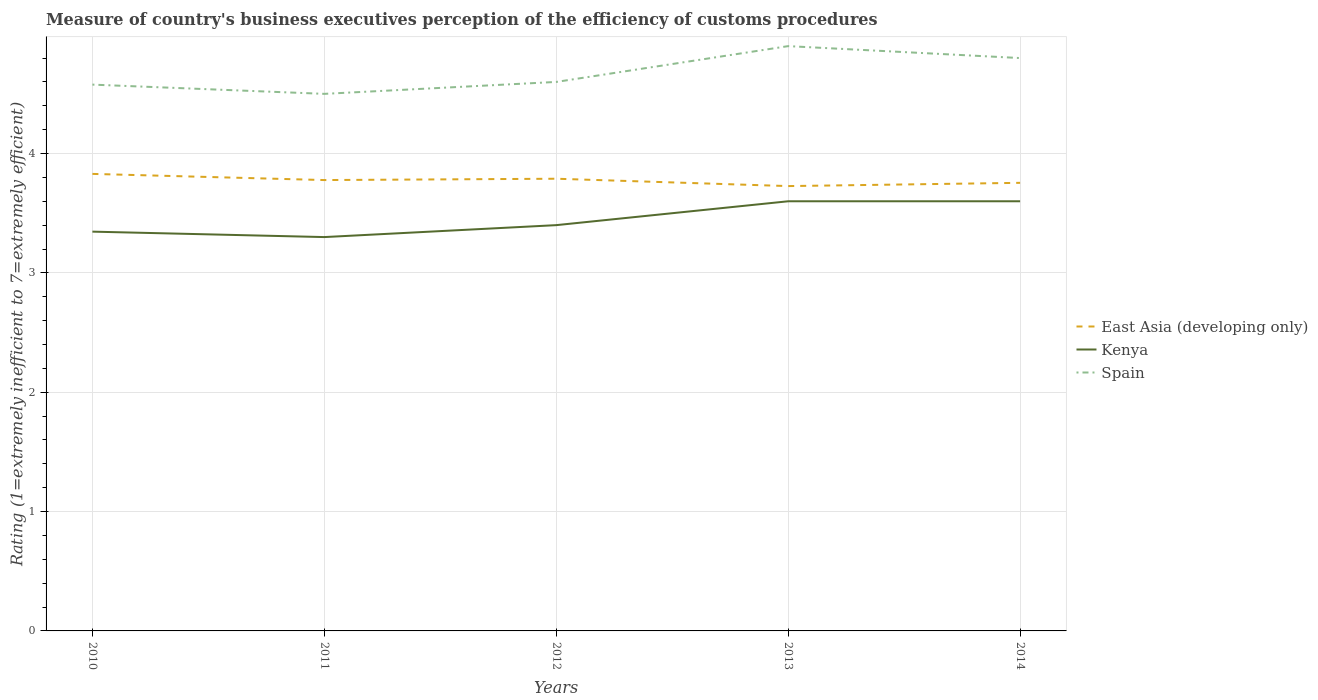How many different coloured lines are there?
Your answer should be compact. 3. Is the number of lines equal to the number of legend labels?
Offer a terse response. Yes. Across all years, what is the maximum rating of the efficiency of customs procedure in Spain?
Keep it short and to the point. 4.5. What is the total rating of the efficiency of customs procedure in East Asia (developing only) in the graph?
Provide a short and direct response. 0.05. What is the difference between the highest and the second highest rating of the efficiency of customs procedure in East Asia (developing only)?
Provide a succinct answer. 0.1. What is the difference between the highest and the lowest rating of the efficiency of customs procedure in East Asia (developing only)?
Your answer should be compact. 3. Is the rating of the efficiency of customs procedure in East Asia (developing only) strictly greater than the rating of the efficiency of customs procedure in Spain over the years?
Make the answer very short. Yes. How many lines are there?
Provide a short and direct response. 3. Where does the legend appear in the graph?
Offer a very short reply. Center right. How are the legend labels stacked?
Offer a very short reply. Vertical. What is the title of the graph?
Keep it short and to the point. Measure of country's business executives perception of the efficiency of customs procedures. Does "Swaziland" appear as one of the legend labels in the graph?
Your response must be concise. No. What is the label or title of the Y-axis?
Offer a terse response. Rating (1=extremely inefficient to 7=extremely efficient). What is the Rating (1=extremely inefficient to 7=extremely efficient) in East Asia (developing only) in 2010?
Your answer should be compact. 3.83. What is the Rating (1=extremely inefficient to 7=extremely efficient) in Kenya in 2010?
Keep it short and to the point. 3.35. What is the Rating (1=extremely inefficient to 7=extremely efficient) in Spain in 2010?
Provide a succinct answer. 4.58. What is the Rating (1=extremely inefficient to 7=extremely efficient) in East Asia (developing only) in 2011?
Provide a succinct answer. 3.78. What is the Rating (1=extremely inefficient to 7=extremely efficient) of Kenya in 2011?
Provide a short and direct response. 3.3. What is the Rating (1=extremely inefficient to 7=extremely efficient) in East Asia (developing only) in 2012?
Your answer should be compact. 3.79. What is the Rating (1=extremely inefficient to 7=extremely efficient) of East Asia (developing only) in 2013?
Provide a succinct answer. 3.73. What is the Rating (1=extremely inefficient to 7=extremely efficient) in Kenya in 2013?
Make the answer very short. 3.6. What is the Rating (1=extremely inefficient to 7=extremely efficient) of East Asia (developing only) in 2014?
Give a very brief answer. 3.75. What is the Rating (1=extremely inefficient to 7=extremely efficient) of Kenya in 2014?
Your answer should be compact. 3.6. Across all years, what is the maximum Rating (1=extremely inefficient to 7=extremely efficient) in East Asia (developing only)?
Keep it short and to the point. 3.83. Across all years, what is the maximum Rating (1=extremely inefficient to 7=extremely efficient) of Kenya?
Your answer should be very brief. 3.6. Across all years, what is the minimum Rating (1=extremely inefficient to 7=extremely efficient) of East Asia (developing only)?
Your answer should be compact. 3.73. Across all years, what is the minimum Rating (1=extremely inefficient to 7=extremely efficient) of Kenya?
Make the answer very short. 3.3. What is the total Rating (1=extremely inefficient to 7=extremely efficient) in East Asia (developing only) in the graph?
Make the answer very short. 18.88. What is the total Rating (1=extremely inefficient to 7=extremely efficient) of Kenya in the graph?
Keep it short and to the point. 17.25. What is the total Rating (1=extremely inefficient to 7=extremely efficient) in Spain in the graph?
Give a very brief answer. 23.38. What is the difference between the Rating (1=extremely inefficient to 7=extremely efficient) in East Asia (developing only) in 2010 and that in 2011?
Your answer should be very brief. 0.05. What is the difference between the Rating (1=extremely inefficient to 7=extremely efficient) of Kenya in 2010 and that in 2011?
Offer a terse response. 0.05. What is the difference between the Rating (1=extremely inefficient to 7=extremely efficient) in Spain in 2010 and that in 2011?
Make the answer very short. 0.08. What is the difference between the Rating (1=extremely inefficient to 7=extremely efficient) of East Asia (developing only) in 2010 and that in 2012?
Your answer should be compact. 0.04. What is the difference between the Rating (1=extremely inefficient to 7=extremely efficient) of Kenya in 2010 and that in 2012?
Your response must be concise. -0.05. What is the difference between the Rating (1=extremely inefficient to 7=extremely efficient) in Spain in 2010 and that in 2012?
Your answer should be very brief. -0.02. What is the difference between the Rating (1=extremely inefficient to 7=extremely efficient) of East Asia (developing only) in 2010 and that in 2013?
Your response must be concise. 0.1. What is the difference between the Rating (1=extremely inefficient to 7=extremely efficient) of Kenya in 2010 and that in 2013?
Provide a short and direct response. -0.25. What is the difference between the Rating (1=extremely inefficient to 7=extremely efficient) in Spain in 2010 and that in 2013?
Your answer should be compact. -0.32. What is the difference between the Rating (1=extremely inefficient to 7=extremely efficient) of East Asia (developing only) in 2010 and that in 2014?
Offer a terse response. 0.07. What is the difference between the Rating (1=extremely inefficient to 7=extremely efficient) in Kenya in 2010 and that in 2014?
Keep it short and to the point. -0.25. What is the difference between the Rating (1=extremely inefficient to 7=extremely efficient) in Spain in 2010 and that in 2014?
Give a very brief answer. -0.22. What is the difference between the Rating (1=extremely inefficient to 7=extremely efficient) of East Asia (developing only) in 2011 and that in 2012?
Offer a very short reply. -0.01. What is the difference between the Rating (1=extremely inefficient to 7=extremely efficient) in Kenya in 2011 and that in 2012?
Your response must be concise. -0.1. What is the difference between the Rating (1=extremely inefficient to 7=extremely efficient) of Spain in 2011 and that in 2012?
Ensure brevity in your answer.  -0.1. What is the difference between the Rating (1=extremely inefficient to 7=extremely efficient) in East Asia (developing only) in 2011 and that in 2013?
Your answer should be very brief. 0.05. What is the difference between the Rating (1=extremely inefficient to 7=extremely efficient) in Kenya in 2011 and that in 2013?
Your answer should be compact. -0.3. What is the difference between the Rating (1=extremely inefficient to 7=extremely efficient) in Spain in 2011 and that in 2013?
Offer a very short reply. -0.4. What is the difference between the Rating (1=extremely inefficient to 7=extremely efficient) of East Asia (developing only) in 2011 and that in 2014?
Your response must be concise. 0.02. What is the difference between the Rating (1=extremely inefficient to 7=extremely efficient) in East Asia (developing only) in 2012 and that in 2013?
Your answer should be very brief. 0.06. What is the difference between the Rating (1=extremely inefficient to 7=extremely efficient) of Kenya in 2012 and that in 2013?
Offer a terse response. -0.2. What is the difference between the Rating (1=extremely inefficient to 7=extremely efficient) in Spain in 2012 and that in 2013?
Your answer should be compact. -0.3. What is the difference between the Rating (1=extremely inefficient to 7=extremely efficient) of East Asia (developing only) in 2012 and that in 2014?
Keep it short and to the point. 0.03. What is the difference between the Rating (1=extremely inefficient to 7=extremely efficient) in Kenya in 2012 and that in 2014?
Your answer should be compact. -0.2. What is the difference between the Rating (1=extremely inefficient to 7=extremely efficient) of East Asia (developing only) in 2013 and that in 2014?
Provide a succinct answer. -0.03. What is the difference between the Rating (1=extremely inefficient to 7=extremely efficient) in Spain in 2013 and that in 2014?
Give a very brief answer. 0.1. What is the difference between the Rating (1=extremely inefficient to 7=extremely efficient) in East Asia (developing only) in 2010 and the Rating (1=extremely inefficient to 7=extremely efficient) in Kenya in 2011?
Make the answer very short. 0.53. What is the difference between the Rating (1=extremely inefficient to 7=extremely efficient) in East Asia (developing only) in 2010 and the Rating (1=extremely inefficient to 7=extremely efficient) in Spain in 2011?
Make the answer very short. -0.67. What is the difference between the Rating (1=extremely inefficient to 7=extremely efficient) in Kenya in 2010 and the Rating (1=extremely inefficient to 7=extremely efficient) in Spain in 2011?
Make the answer very short. -1.15. What is the difference between the Rating (1=extremely inefficient to 7=extremely efficient) in East Asia (developing only) in 2010 and the Rating (1=extremely inefficient to 7=extremely efficient) in Kenya in 2012?
Give a very brief answer. 0.43. What is the difference between the Rating (1=extremely inefficient to 7=extremely efficient) of East Asia (developing only) in 2010 and the Rating (1=extremely inefficient to 7=extremely efficient) of Spain in 2012?
Keep it short and to the point. -0.77. What is the difference between the Rating (1=extremely inefficient to 7=extremely efficient) in Kenya in 2010 and the Rating (1=extremely inefficient to 7=extremely efficient) in Spain in 2012?
Your answer should be very brief. -1.25. What is the difference between the Rating (1=extremely inefficient to 7=extremely efficient) of East Asia (developing only) in 2010 and the Rating (1=extremely inefficient to 7=extremely efficient) of Kenya in 2013?
Provide a short and direct response. 0.23. What is the difference between the Rating (1=extremely inefficient to 7=extremely efficient) in East Asia (developing only) in 2010 and the Rating (1=extremely inefficient to 7=extremely efficient) in Spain in 2013?
Ensure brevity in your answer.  -1.07. What is the difference between the Rating (1=extremely inefficient to 7=extremely efficient) of Kenya in 2010 and the Rating (1=extremely inefficient to 7=extremely efficient) of Spain in 2013?
Give a very brief answer. -1.55. What is the difference between the Rating (1=extremely inefficient to 7=extremely efficient) of East Asia (developing only) in 2010 and the Rating (1=extremely inefficient to 7=extremely efficient) of Kenya in 2014?
Your answer should be very brief. 0.23. What is the difference between the Rating (1=extremely inefficient to 7=extremely efficient) of East Asia (developing only) in 2010 and the Rating (1=extremely inefficient to 7=extremely efficient) of Spain in 2014?
Your answer should be very brief. -0.97. What is the difference between the Rating (1=extremely inefficient to 7=extremely efficient) of Kenya in 2010 and the Rating (1=extremely inefficient to 7=extremely efficient) of Spain in 2014?
Offer a terse response. -1.45. What is the difference between the Rating (1=extremely inefficient to 7=extremely efficient) in East Asia (developing only) in 2011 and the Rating (1=extremely inefficient to 7=extremely efficient) in Kenya in 2012?
Provide a succinct answer. 0.38. What is the difference between the Rating (1=extremely inefficient to 7=extremely efficient) of East Asia (developing only) in 2011 and the Rating (1=extremely inefficient to 7=extremely efficient) of Spain in 2012?
Ensure brevity in your answer.  -0.82. What is the difference between the Rating (1=extremely inefficient to 7=extremely efficient) in East Asia (developing only) in 2011 and the Rating (1=extremely inefficient to 7=extremely efficient) in Kenya in 2013?
Your answer should be very brief. 0.18. What is the difference between the Rating (1=extremely inefficient to 7=extremely efficient) in East Asia (developing only) in 2011 and the Rating (1=extremely inefficient to 7=extremely efficient) in Spain in 2013?
Your response must be concise. -1.12. What is the difference between the Rating (1=extremely inefficient to 7=extremely efficient) of East Asia (developing only) in 2011 and the Rating (1=extremely inefficient to 7=extremely efficient) of Kenya in 2014?
Provide a short and direct response. 0.18. What is the difference between the Rating (1=extremely inefficient to 7=extremely efficient) of East Asia (developing only) in 2011 and the Rating (1=extremely inefficient to 7=extremely efficient) of Spain in 2014?
Give a very brief answer. -1.02. What is the difference between the Rating (1=extremely inefficient to 7=extremely efficient) of Kenya in 2011 and the Rating (1=extremely inefficient to 7=extremely efficient) of Spain in 2014?
Offer a terse response. -1.5. What is the difference between the Rating (1=extremely inefficient to 7=extremely efficient) of East Asia (developing only) in 2012 and the Rating (1=extremely inefficient to 7=extremely efficient) of Kenya in 2013?
Keep it short and to the point. 0.19. What is the difference between the Rating (1=extremely inefficient to 7=extremely efficient) of East Asia (developing only) in 2012 and the Rating (1=extremely inefficient to 7=extremely efficient) of Spain in 2013?
Ensure brevity in your answer.  -1.11. What is the difference between the Rating (1=extremely inefficient to 7=extremely efficient) in East Asia (developing only) in 2012 and the Rating (1=extremely inefficient to 7=extremely efficient) in Kenya in 2014?
Keep it short and to the point. 0.19. What is the difference between the Rating (1=extremely inefficient to 7=extremely efficient) in East Asia (developing only) in 2012 and the Rating (1=extremely inefficient to 7=extremely efficient) in Spain in 2014?
Your response must be concise. -1.01. What is the difference between the Rating (1=extremely inefficient to 7=extremely efficient) of Kenya in 2012 and the Rating (1=extremely inefficient to 7=extremely efficient) of Spain in 2014?
Make the answer very short. -1.4. What is the difference between the Rating (1=extremely inefficient to 7=extremely efficient) in East Asia (developing only) in 2013 and the Rating (1=extremely inefficient to 7=extremely efficient) in Kenya in 2014?
Offer a terse response. 0.13. What is the difference between the Rating (1=extremely inefficient to 7=extremely efficient) in East Asia (developing only) in 2013 and the Rating (1=extremely inefficient to 7=extremely efficient) in Spain in 2014?
Your response must be concise. -1.07. What is the average Rating (1=extremely inefficient to 7=extremely efficient) in East Asia (developing only) per year?
Offer a very short reply. 3.78. What is the average Rating (1=extremely inefficient to 7=extremely efficient) of Kenya per year?
Make the answer very short. 3.45. What is the average Rating (1=extremely inefficient to 7=extremely efficient) in Spain per year?
Offer a very short reply. 4.68. In the year 2010, what is the difference between the Rating (1=extremely inefficient to 7=extremely efficient) of East Asia (developing only) and Rating (1=extremely inefficient to 7=extremely efficient) of Kenya?
Provide a succinct answer. 0.48. In the year 2010, what is the difference between the Rating (1=extremely inefficient to 7=extremely efficient) of East Asia (developing only) and Rating (1=extremely inefficient to 7=extremely efficient) of Spain?
Your answer should be very brief. -0.75. In the year 2010, what is the difference between the Rating (1=extremely inefficient to 7=extremely efficient) of Kenya and Rating (1=extremely inefficient to 7=extremely efficient) of Spain?
Provide a short and direct response. -1.23. In the year 2011, what is the difference between the Rating (1=extremely inefficient to 7=extremely efficient) of East Asia (developing only) and Rating (1=extremely inefficient to 7=extremely efficient) of Kenya?
Provide a succinct answer. 0.48. In the year 2011, what is the difference between the Rating (1=extremely inefficient to 7=extremely efficient) in East Asia (developing only) and Rating (1=extremely inefficient to 7=extremely efficient) in Spain?
Keep it short and to the point. -0.72. In the year 2011, what is the difference between the Rating (1=extremely inefficient to 7=extremely efficient) in Kenya and Rating (1=extremely inefficient to 7=extremely efficient) in Spain?
Your response must be concise. -1.2. In the year 2012, what is the difference between the Rating (1=extremely inefficient to 7=extremely efficient) in East Asia (developing only) and Rating (1=extremely inefficient to 7=extremely efficient) in Kenya?
Your answer should be compact. 0.39. In the year 2012, what is the difference between the Rating (1=extremely inefficient to 7=extremely efficient) of East Asia (developing only) and Rating (1=extremely inefficient to 7=extremely efficient) of Spain?
Make the answer very short. -0.81. In the year 2013, what is the difference between the Rating (1=extremely inefficient to 7=extremely efficient) of East Asia (developing only) and Rating (1=extremely inefficient to 7=extremely efficient) of Kenya?
Your answer should be compact. 0.13. In the year 2013, what is the difference between the Rating (1=extremely inefficient to 7=extremely efficient) of East Asia (developing only) and Rating (1=extremely inefficient to 7=extremely efficient) of Spain?
Your answer should be compact. -1.17. In the year 2013, what is the difference between the Rating (1=extremely inefficient to 7=extremely efficient) of Kenya and Rating (1=extremely inefficient to 7=extremely efficient) of Spain?
Your response must be concise. -1.3. In the year 2014, what is the difference between the Rating (1=extremely inefficient to 7=extremely efficient) of East Asia (developing only) and Rating (1=extremely inefficient to 7=extremely efficient) of Kenya?
Make the answer very short. 0.15. In the year 2014, what is the difference between the Rating (1=extremely inefficient to 7=extremely efficient) in East Asia (developing only) and Rating (1=extremely inefficient to 7=extremely efficient) in Spain?
Provide a short and direct response. -1.05. In the year 2014, what is the difference between the Rating (1=extremely inefficient to 7=extremely efficient) in Kenya and Rating (1=extremely inefficient to 7=extremely efficient) in Spain?
Make the answer very short. -1.2. What is the ratio of the Rating (1=extremely inefficient to 7=extremely efficient) of East Asia (developing only) in 2010 to that in 2011?
Offer a very short reply. 1.01. What is the ratio of the Rating (1=extremely inefficient to 7=extremely efficient) in Kenya in 2010 to that in 2011?
Make the answer very short. 1.01. What is the ratio of the Rating (1=extremely inefficient to 7=extremely efficient) in Spain in 2010 to that in 2011?
Give a very brief answer. 1.02. What is the ratio of the Rating (1=extremely inefficient to 7=extremely efficient) of East Asia (developing only) in 2010 to that in 2012?
Provide a succinct answer. 1.01. What is the ratio of the Rating (1=extremely inefficient to 7=extremely efficient) of Kenya in 2010 to that in 2012?
Your response must be concise. 0.98. What is the ratio of the Rating (1=extremely inefficient to 7=extremely efficient) in Spain in 2010 to that in 2012?
Give a very brief answer. 1. What is the ratio of the Rating (1=extremely inefficient to 7=extremely efficient) in East Asia (developing only) in 2010 to that in 2013?
Offer a very short reply. 1.03. What is the ratio of the Rating (1=extremely inefficient to 7=extremely efficient) in Kenya in 2010 to that in 2013?
Your answer should be compact. 0.93. What is the ratio of the Rating (1=extremely inefficient to 7=extremely efficient) in Spain in 2010 to that in 2013?
Keep it short and to the point. 0.93. What is the ratio of the Rating (1=extremely inefficient to 7=extremely efficient) in East Asia (developing only) in 2010 to that in 2014?
Provide a short and direct response. 1.02. What is the ratio of the Rating (1=extremely inefficient to 7=extremely efficient) of Kenya in 2010 to that in 2014?
Provide a succinct answer. 0.93. What is the ratio of the Rating (1=extremely inefficient to 7=extremely efficient) of Spain in 2010 to that in 2014?
Your answer should be very brief. 0.95. What is the ratio of the Rating (1=extremely inefficient to 7=extremely efficient) in East Asia (developing only) in 2011 to that in 2012?
Make the answer very short. 1. What is the ratio of the Rating (1=extremely inefficient to 7=extremely efficient) of Kenya in 2011 to that in 2012?
Your answer should be compact. 0.97. What is the ratio of the Rating (1=extremely inefficient to 7=extremely efficient) of Spain in 2011 to that in 2012?
Ensure brevity in your answer.  0.98. What is the ratio of the Rating (1=extremely inefficient to 7=extremely efficient) of East Asia (developing only) in 2011 to that in 2013?
Offer a very short reply. 1.01. What is the ratio of the Rating (1=extremely inefficient to 7=extremely efficient) in Kenya in 2011 to that in 2013?
Give a very brief answer. 0.92. What is the ratio of the Rating (1=extremely inefficient to 7=extremely efficient) of Spain in 2011 to that in 2013?
Provide a succinct answer. 0.92. What is the ratio of the Rating (1=extremely inefficient to 7=extremely efficient) in East Asia (developing only) in 2011 to that in 2014?
Offer a very short reply. 1.01. What is the ratio of the Rating (1=extremely inefficient to 7=extremely efficient) of Kenya in 2011 to that in 2014?
Your response must be concise. 0.92. What is the ratio of the Rating (1=extremely inefficient to 7=extremely efficient) in East Asia (developing only) in 2012 to that in 2013?
Keep it short and to the point. 1.02. What is the ratio of the Rating (1=extremely inefficient to 7=extremely efficient) in Kenya in 2012 to that in 2013?
Provide a succinct answer. 0.94. What is the ratio of the Rating (1=extremely inefficient to 7=extremely efficient) of Spain in 2012 to that in 2013?
Provide a short and direct response. 0.94. What is the ratio of the Rating (1=extremely inefficient to 7=extremely efficient) in East Asia (developing only) in 2012 to that in 2014?
Your answer should be very brief. 1.01. What is the ratio of the Rating (1=extremely inefficient to 7=extremely efficient) of East Asia (developing only) in 2013 to that in 2014?
Provide a short and direct response. 0.99. What is the ratio of the Rating (1=extremely inefficient to 7=extremely efficient) of Spain in 2013 to that in 2014?
Your answer should be very brief. 1.02. What is the difference between the highest and the second highest Rating (1=extremely inefficient to 7=extremely efficient) of East Asia (developing only)?
Ensure brevity in your answer.  0.04. What is the difference between the highest and the second highest Rating (1=extremely inefficient to 7=extremely efficient) of Kenya?
Your response must be concise. 0. What is the difference between the highest and the second highest Rating (1=extremely inefficient to 7=extremely efficient) of Spain?
Provide a short and direct response. 0.1. What is the difference between the highest and the lowest Rating (1=extremely inefficient to 7=extremely efficient) in East Asia (developing only)?
Offer a terse response. 0.1. What is the difference between the highest and the lowest Rating (1=extremely inefficient to 7=extremely efficient) of Spain?
Offer a terse response. 0.4. 